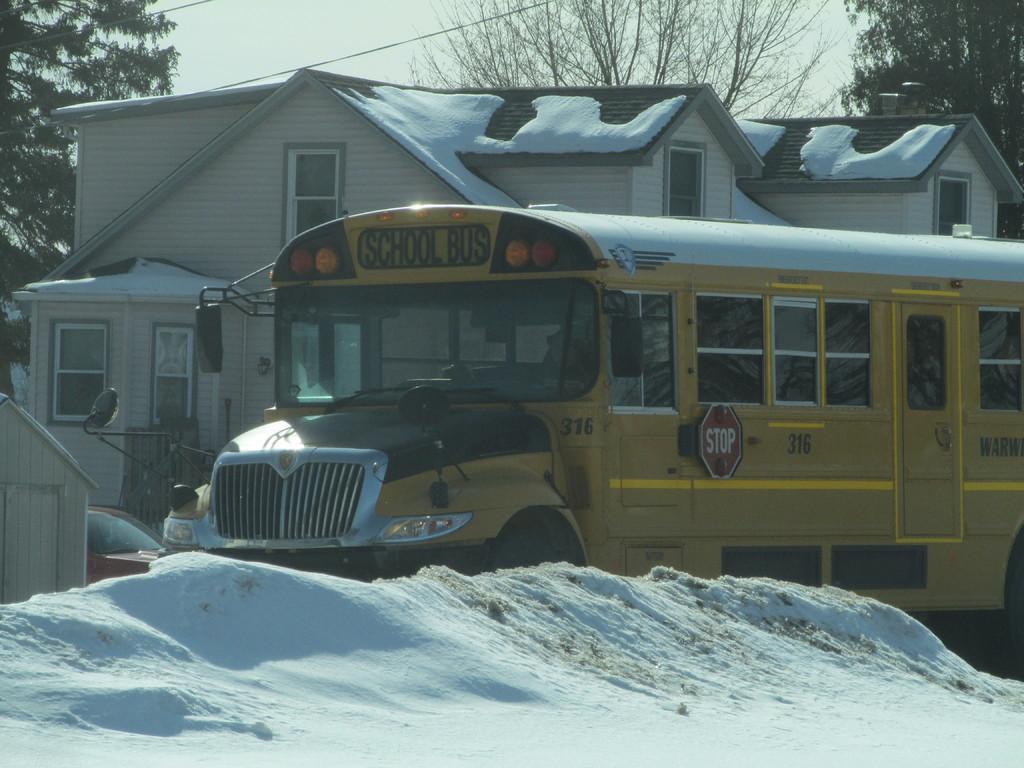Can you describe this image briefly? In this picture I can see the snow in front and in the middle of this image, I can see a car and a bus. In the background I can see a building on which there is snow and I can see the trees and the sky. 